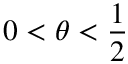Convert formula to latex. <formula><loc_0><loc_0><loc_500><loc_500>0 < \theta < \frac { 1 } { 2 }</formula> 